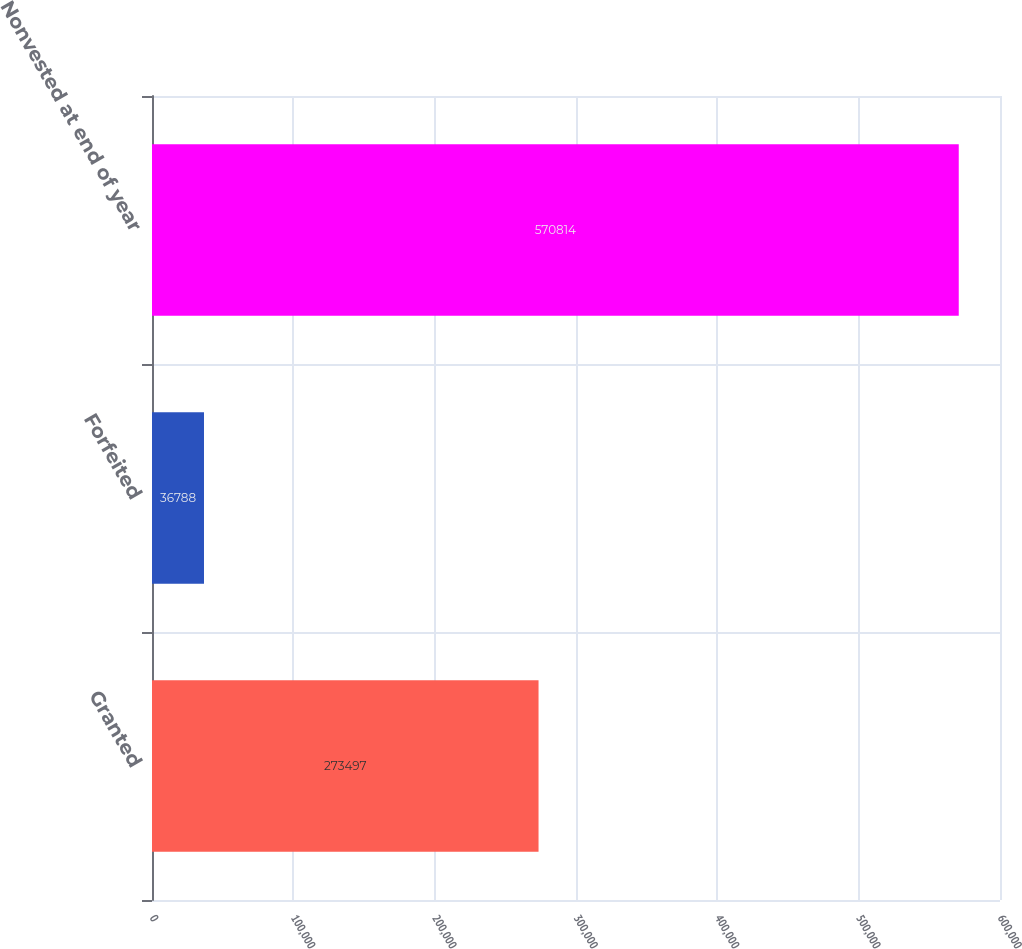Convert chart. <chart><loc_0><loc_0><loc_500><loc_500><bar_chart><fcel>Granted<fcel>Forfeited<fcel>Nonvested at end of year<nl><fcel>273497<fcel>36788<fcel>570814<nl></chart> 